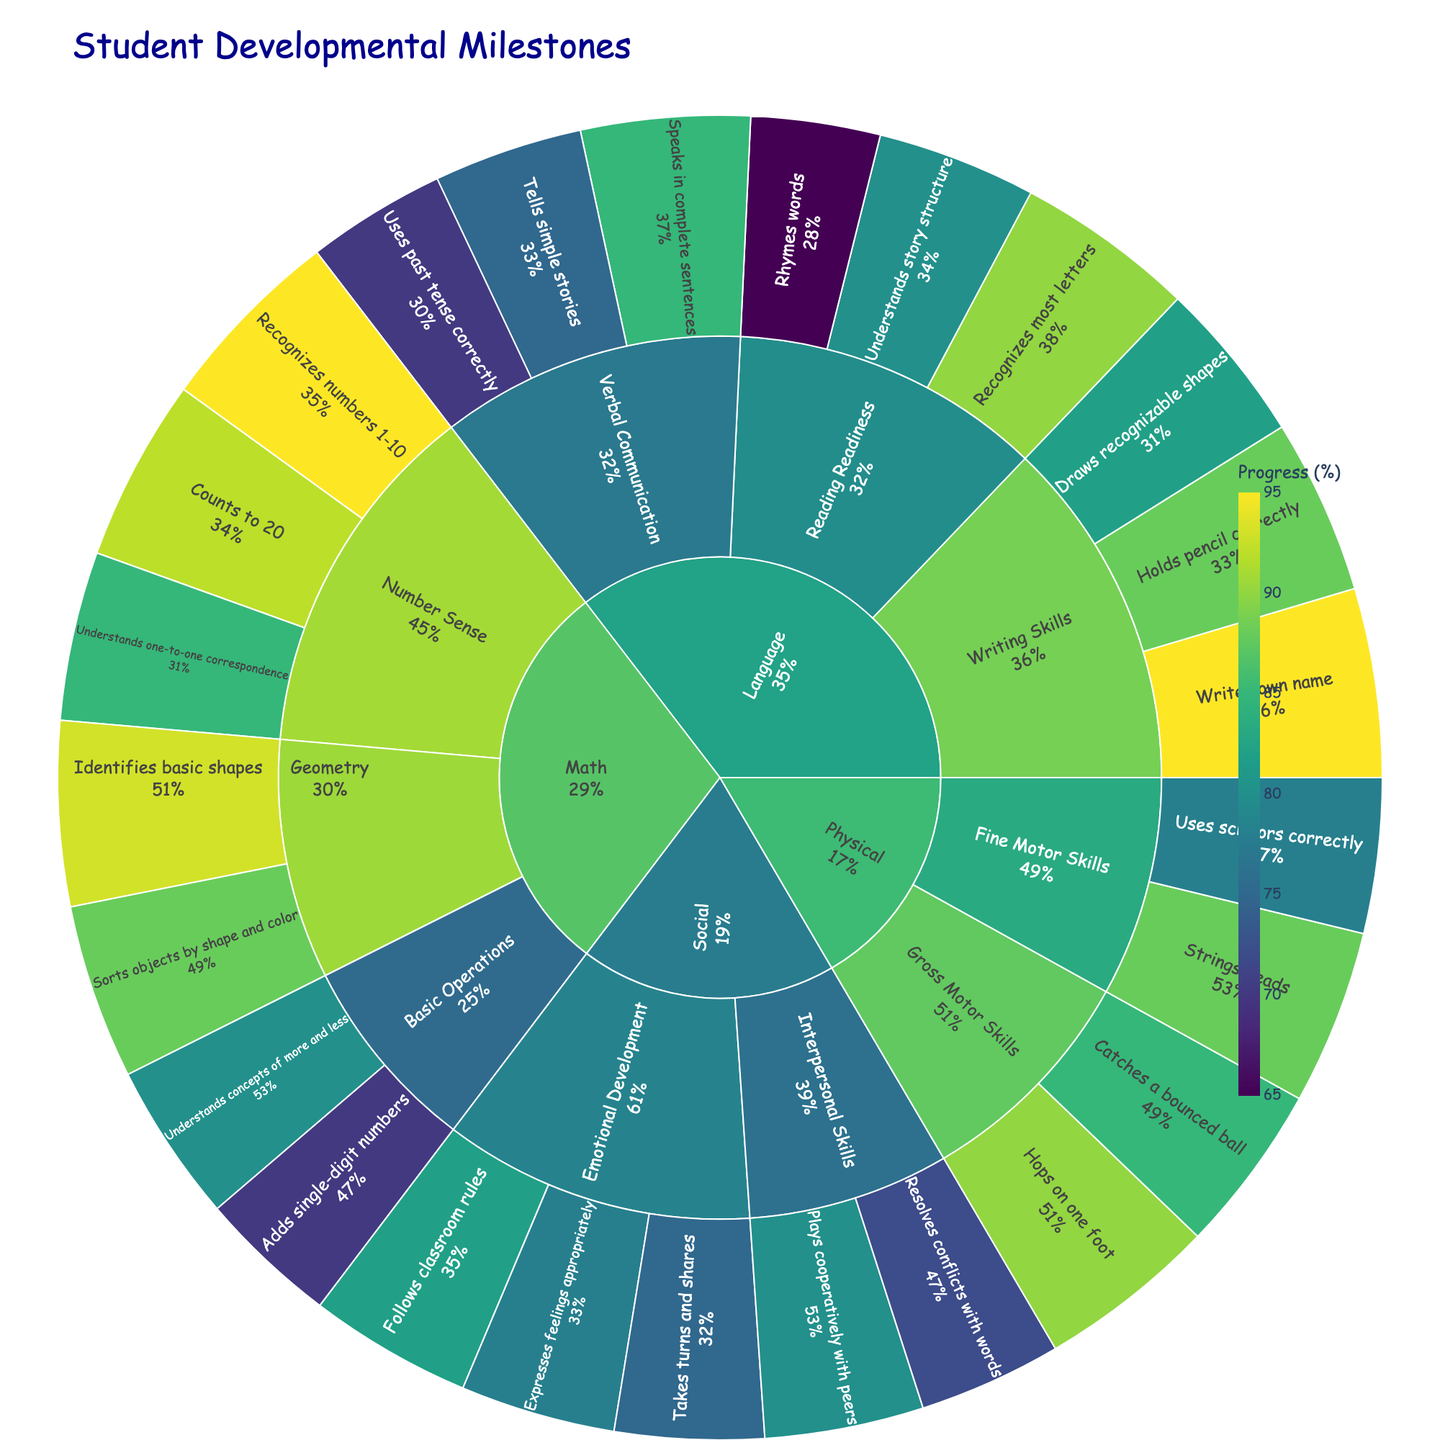What is the title of the Sunburst Plot? The title is usually found at the top of the plot. By reading the label situated at the upper side, we can see the title.
Answer: Student Developmental Milestones Which skill area has the highest individual milestone progress? By examining the outermost sections of the sunburst plot, which represent individual milestones, we can find the one with the maximum progress value.
Answer: Writing: Writes own name (95%) What percentage of students achieved 'Uses past tense correctly' under Verbal Communication? Locate the 'Verbal Communication' category under 'Language' and then look for 'Uses past tense correctly'. The plot shows the progress directly.
Answer: 70% How many categories are there under the 'Physical' skill area? Look at the segments branching out directly from 'Physical'. Count these segments to determine the number of categories.
Answer: 2 Which milestone under 'Number Sense' has the higher achievement rate: 'Counts to 20' or 'Recognizes numbers 1-10'? Find 'Number Sense' under 'Math' and compare the progress percentages of 'Counts to 20' and 'Recognizes numbers 1-10'.
Answer: Recognizes numbers 1-10 (95%) Compare 'Expresses feelings appropriately' and 'Plays cooperatively with peers'. Which has a lower progress rate? Identify these two milestones under the 'Social' skill area and note their progress percentages.
Answer: Plays cooperatively with peers What is the average progress achieved across all 'Writing Skills' milestones? Locate the three milestones under 'Writing Skills' within 'Language'. Sum their progress values and divide by three. Calculation: (95 + 88 + 82) / 3 = 265 / 3 = 88.33 (approximately)
Answer: 88.33% Which milestone under 'Emotional Development' shows the least progress? In the 'Emotional Development' category under 'Social', compare the progress of all listed milestones.
Answer: Takes turns and shares (75%) Which two categories under 'Math' are the focus of the milestones? Inspect the branches extending from 'Math' to see the names of the categories.
Answer: Number Sense, Basic Operations, and Geometry What is the total progress for all milestones under 'Reading Readiness'? Sum the progress values for the three milestones under 'Reading Readiness' within the 'Language' skill. Calculation: 90 + 80 + 65 = 235
Answer: 235 